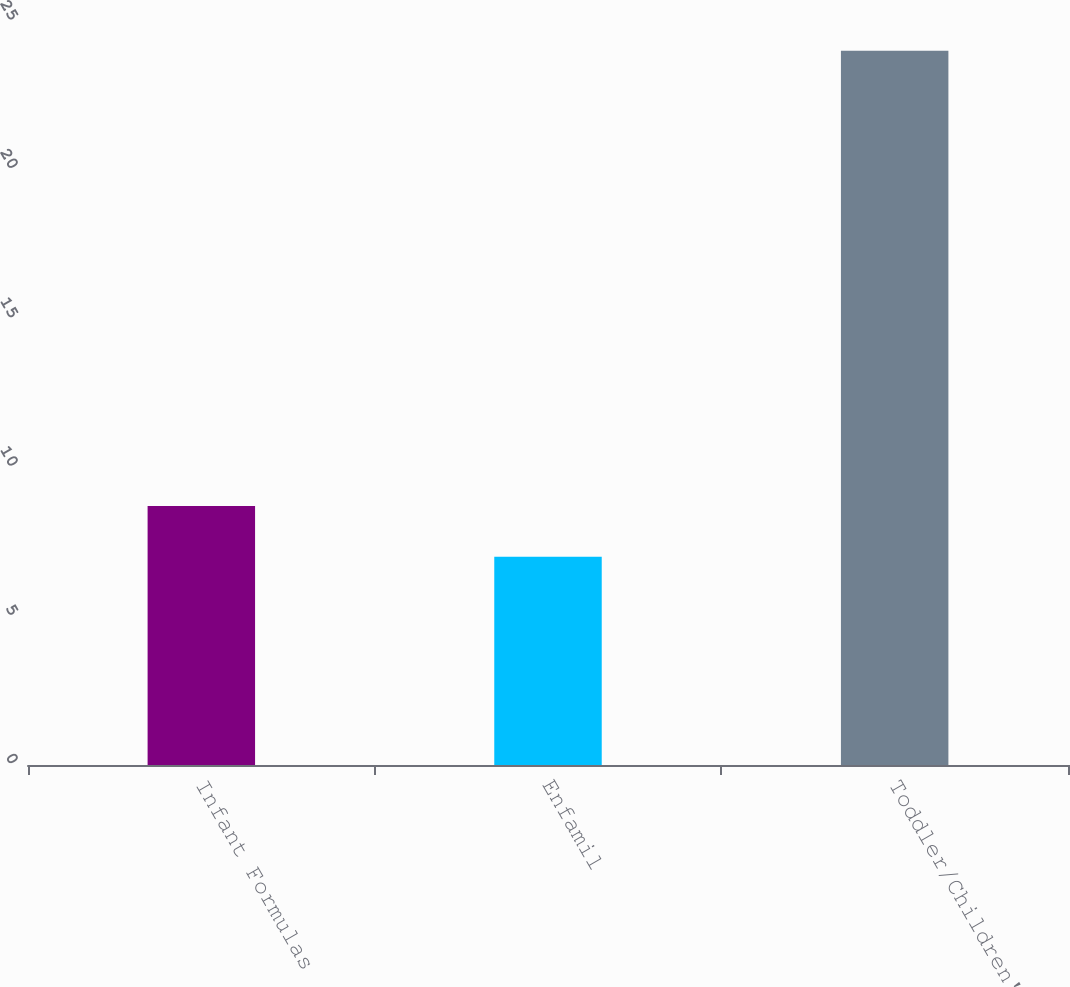Convert chart. <chart><loc_0><loc_0><loc_500><loc_500><bar_chart><fcel>Infant Formulas<fcel>Enfamil<fcel>Toddler/Children's<nl><fcel>8.7<fcel>7<fcel>24<nl></chart> 